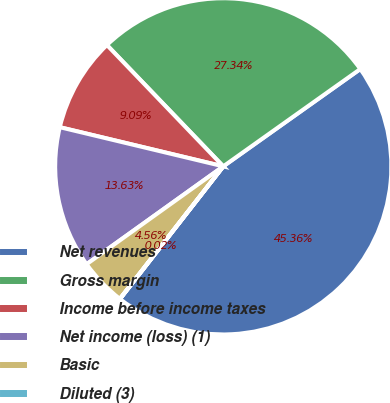<chart> <loc_0><loc_0><loc_500><loc_500><pie_chart><fcel>Net revenues<fcel>Gross margin<fcel>Income before income taxes<fcel>Net income (loss) (1)<fcel>Basic<fcel>Diluted (3)<nl><fcel>45.36%<fcel>27.34%<fcel>9.09%<fcel>13.63%<fcel>4.56%<fcel>0.02%<nl></chart> 